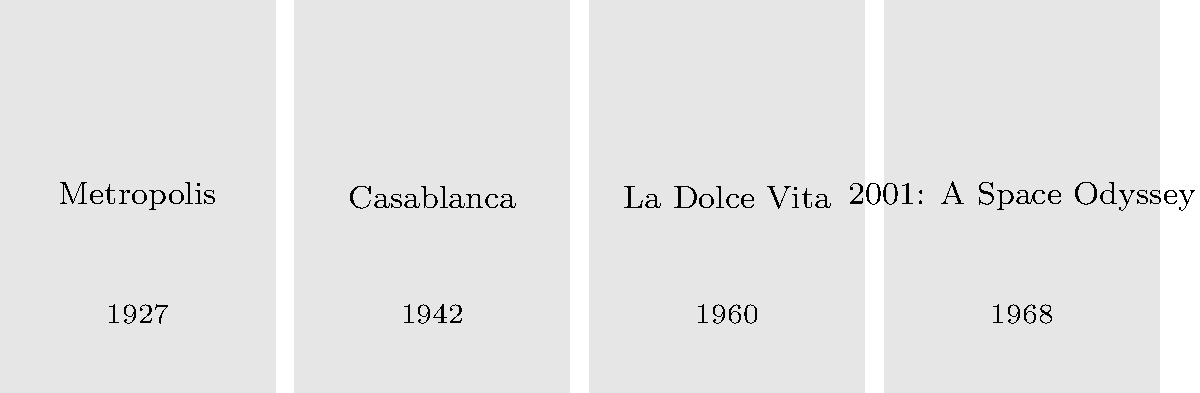Order the following classic film posters chronologically based on their design elements and visual styles, from earliest to latest: To answer this question, we need to analyze the design elements and visual styles of each film poster, considering the typical aesthetics of their respective eras:

1. "Metropolis" (1927): This German expressionist science fiction film would likely have a poster with Art Deco influences, featuring bold geometric shapes and stylized figures. The visual style would be characteristic of the late 1920s.

2. "Casablanca" (1942): As a Hollywood classic from the early 1940s, its poster would probably feature realistic portraits of the lead actors, with a more subdued color palette typical of wartime cinema advertising.

3. "La Dolce Vita" (1960): Being an Italian film from the beginning of the 1960s, its poster might incorporate elements of mid-century modern design, possibly with more abstract or stylized imagery reflecting the film's avant-garde nature.

4. "2001: A Space Odyssey" (1968): As a late 1960s science fiction film, its poster would likely feature psychedelic or minimalist design elements, possibly incorporating space imagery and bold, futuristic typography.

Based on these design considerations, the chronological order from earliest to latest would be:

Metropolis (1927) → Casablanca (1942) → La Dolce Vita (1960) → 2001: A Space Odyssey (1968)
Answer: Metropolis, Casablanca, La Dolce Vita, 2001: A Space Odyssey 